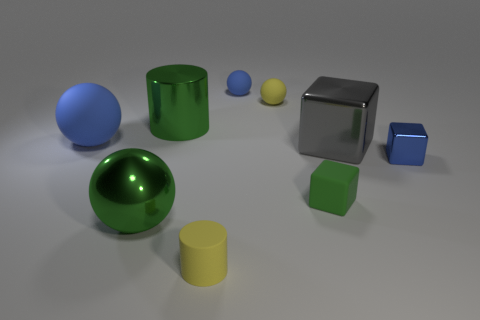Is the shape of the large blue thing the same as the yellow matte object behind the big green sphere? Yes, the large blue object, which is a sphere, shares the same geometric shape as the yellow matte object in the background. Both are spherical, though they differ in size and texture. 